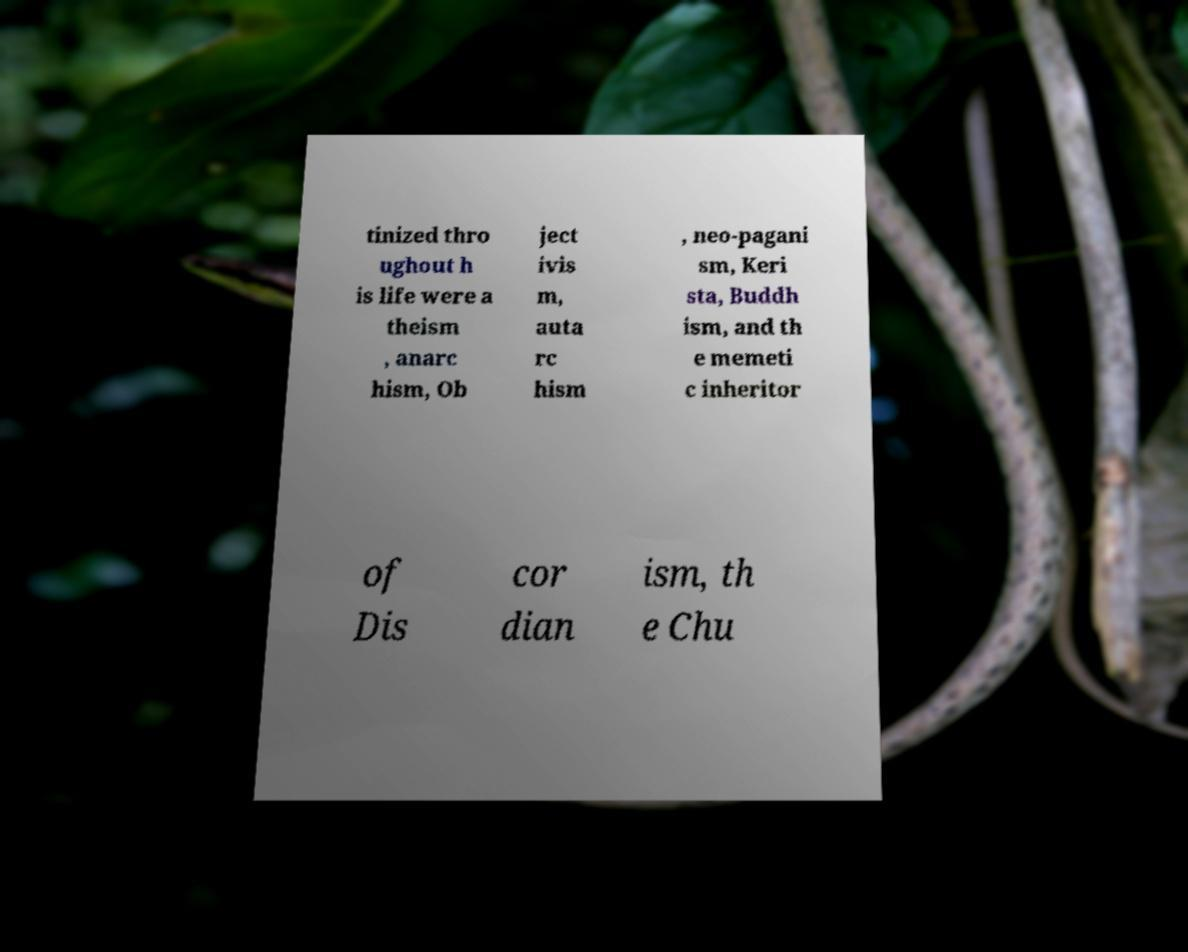Could you extract and type out the text from this image? tinized thro ughout h is life were a theism , anarc hism, Ob ject ivis m, auta rc hism , neo-pagani sm, Keri sta, Buddh ism, and th e memeti c inheritor of Dis cor dian ism, th e Chu 